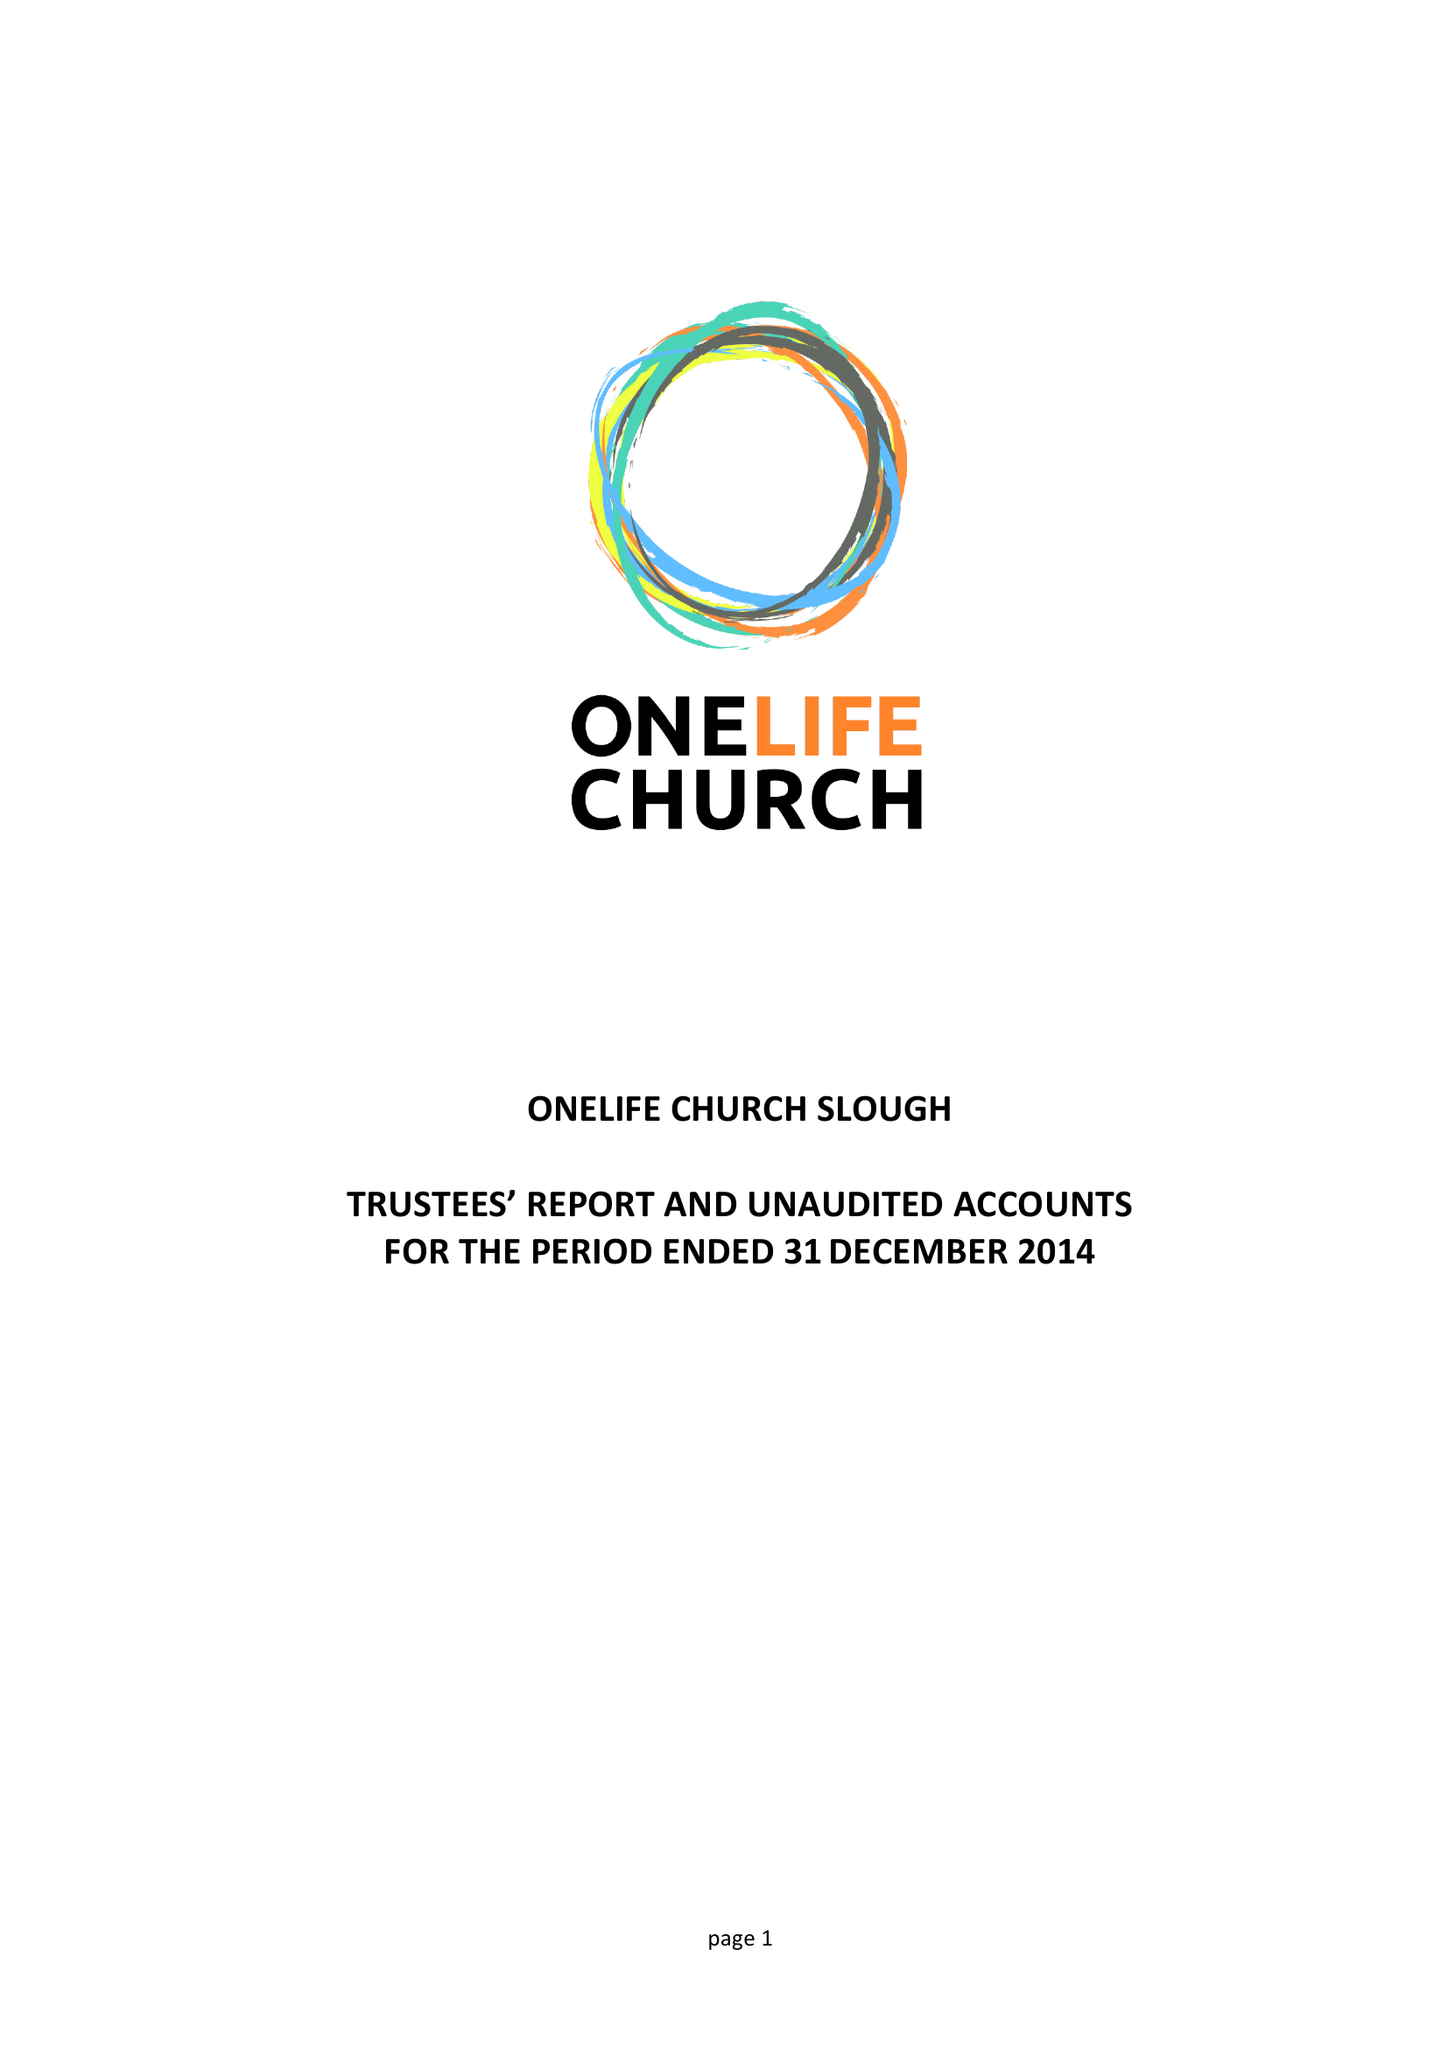What is the value for the report_date?
Answer the question using a single word or phrase. 2014-12-31 